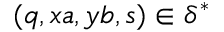<formula> <loc_0><loc_0><loc_500><loc_500>( q , x a , y b , s ) \in \delta ^ { * }</formula> 